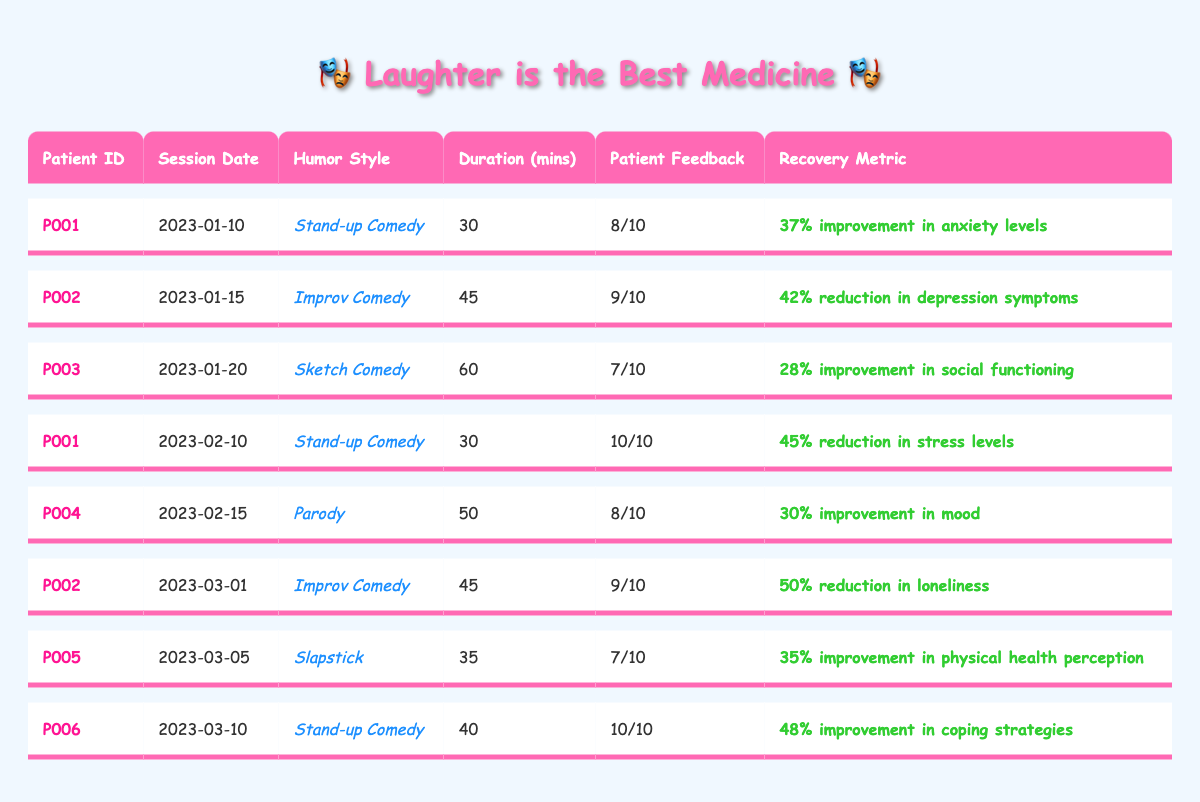What is the humor style used in the longest therapy session? The longest therapy session is 60 minutes for patient P003, which uses "Sketch Comedy" as the humor style.
Answer: Sketch Comedy How many patients had therapy sessions lasting 45 minutes? There are two sessions lasting 45 minutes, one for patient P002 on January 15 and another for patient P002 on March 1.
Answer: 2 Did patient P001 show improvement in anxiety levels after therapy? Yes, patient P001 reported a 37% improvement in anxiety levels after their session on January 10.
Answer: Yes Which patient had the highest feedback score and what was the recovery metric? Patient P001 had the highest feedback score of 10 after the session on February 10, with a recovery metric of 45% reduction in stress levels.
Answer: Patient P001; 45% reduction in stress levels What is the average feedback score from all therapy sessions? There are 8 sessions, and the total feedback scores add up to 8 + 9 + 7 + 10 + 8 + 9 + 7 + 10 = 68. The average is 68/8 = 8.5.
Answer: 8.5 How many recovery metrics indicate improvement in social functioning? Only one recovery metric indicates improvement in social functioning for patient P003, who had a 28% improvement.
Answer: 1 Which humor style had the best patient feedback score based on the data? The highest feedback score of 10 was given in two instances: for "Stand-up Comedy" by patient P001 and for "Stand-up Comedy" by patient P006.
Answer: Stand-up Comedy Was there a decrease in loneliness reported after therapy sessions? Yes, patient P002 reported a 50% reduction in loneliness after their session on March 1.
Answer: Yes How does the recovery metric for patient P005 compare to that of patient P004? Patient P005 had a 35% improvement in physical health perception, while patient P004 had a 30% improvement in mood, showing patient P005 had a greater percentage of improvement.
Answer: Patient P005's improvement is higher What is the total duration of all therapy sessions combined? The total duration is 30 + 45 + 60 + 30 + 50 + 45 + 35 + 40 = 335 minutes.
Answer: 335 minutes 